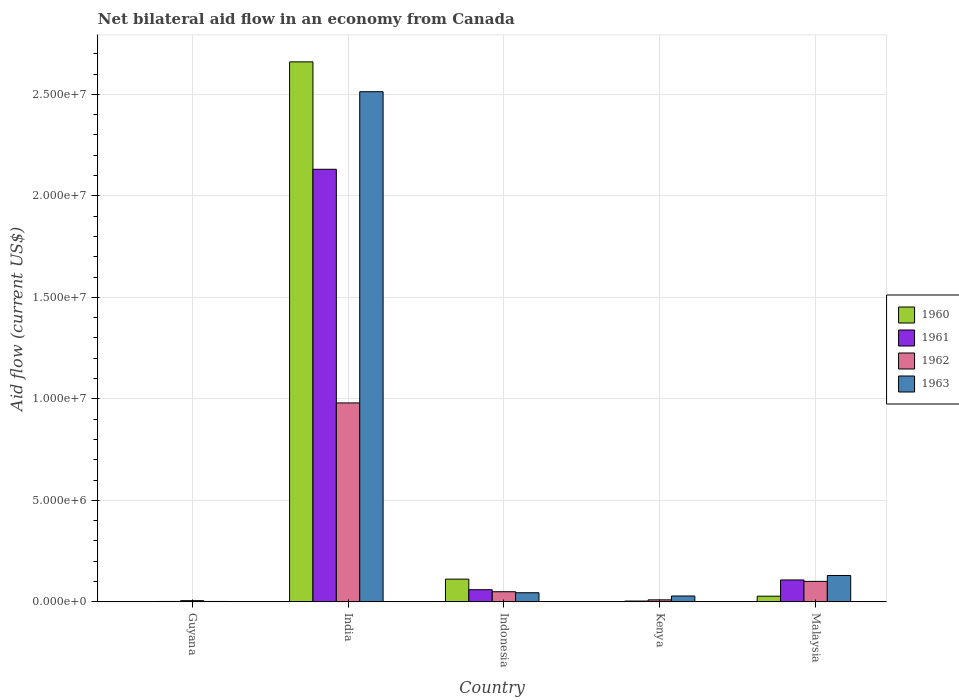How many different coloured bars are there?
Your answer should be very brief. 4. How many groups of bars are there?
Provide a short and direct response. 5. How many bars are there on the 1st tick from the left?
Make the answer very short. 4. What is the label of the 1st group of bars from the left?
Provide a short and direct response. Guyana. In how many cases, is the number of bars for a given country not equal to the number of legend labels?
Your answer should be compact. 0. What is the net bilateral aid flow in 1963 in Guyana?
Make the answer very short. 2.00e+04. Across all countries, what is the maximum net bilateral aid flow in 1963?
Keep it short and to the point. 2.51e+07. In which country was the net bilateral aid flow in 1960 minimum?
Provide a short and direct response. Guyana. What is the total net bilateral aid flow in 1961 in the graph?
Your answer should be compact. 2.30e+07. What is the difference between the net bilateral aid flow in 1961 in Guyana and that in Indonesia?
Keep it short and to the point. -5.80e+05. What is the difference between the net bilateral aid flow in 1963 in Kenya and the net bilateral aid flow in 1960 in India?
Keep it short and to the point. -2.63e+07. What is the average net bilateral aid flow in 1963 per country?
Your response must be concise. 5.44e+06. What is the difference between the net bilateral aid flow of/in 1963 and net bilateral aid flow of/in 1962 in India?
Your answer should be compact. 1.53e+07. In how many countries, is the net bilateral aid flow in 1961 greater than 24000000 US$?
Provide a short and direct response. 0. What is the ratio of the net bilateral aid flow in 1960 in Kenya to that in Malaysia?
Keep it short and to the point. 0.04. Is the difference between the net bilateral aid flow in 1963 in India and Malaysia greater than the difference between the net bilateral aid flow in 1962 in India and Malaysia?
Your answer should be compact. Yes. What is the difference between the highest and the second highest net bilateral aid flow in 1961?
Provide a succinct answer. 2.07e+07. What is the difference between the highest and the lowest net bilateral aid flow in 1961?
Provide a succinct answer. 2.13e+07. In how many countries, is the net bilateral aid flow in 1960 greater than the average net bilateral aid flow in 1960 taken over all countries?
Your answer should be compact. 1. Is it the case that in every country, the sum of the net bilateral aid flow in 1960 and net bilateral aid flow in 1961 is greater than the sum of net bilateral aid flow in 1963 and net bilateral aid flow in 1962?
Provide a succinct answer. No. What does the 3rd bar from the left in Indonesia represents?
Keep it short and to the point. 1962. What does the 1st bar from the right in Kenya represents?
Offer a terse response. 1963. Are all the bars in the graph horizontal?
Offer a very short reply. No. How many countries are there in the graph?
Make the answer very short. 5. What is the difference between two consecutive major ticks on the Y-axis?
Offer a terse response. 5.00e+06. Are the values on the major ticks of Y-axis written in scientific E-notation?
Your response must be concise. Yes. Where does the legend appear in the graph?
Give a very brief answer. Center right. How are the legend labels stacked?
Ensure brevity in your answer.  Vertical. What is the title of the graph?
Provide a short and direct response. Net bilateral aid flow in an economy from Canada. Does "1985" appear as one of the legend labels in the graph?
Provide a succinct answer. No. What is the label or title of the Y-axis?
Give a very brief answer. Aid flow (current US$). What is the Aid flow (current US$) of 1960 in Guyana?
Make the answer very short. 10000. What is the Aid flow (current US$) in 1961 in Guyana?
Provide a short and direct response. 2.00e+04. What is the Aid flow (current US$) in 1962 in Guyana?
Offer a terse response. 6.00e+04. What is the Aid flow (current US$) in 1960 in India?
Make the answer very short. 2.66e+07. What is the Aid flow (current US$) of 1961 in India?
Ensure brevity in your answer.  2.13e+07. What is the Aid flow (current US$) of 1962 in India?
Your answer should be very brief. 9.80e+06. What is the Aid flow (current US$) in 1963 in India?
Ensure brevity in your answer.  2.51e+07. What is the Aid flow (current US$) in 1960 in Indonesia?
Make the answer very short. 1.12e+06. What is the Aid flow (current US$) of 1961 in Indonesia?
Provide a short and direct response. 6.00e+05. What is the Aid flow (current US$) of 1962 in Indonesia?
Your answer should be very brief. 5.00e+05. What is the Aid flow (current US$) in 1961 in Kenya?
Give a very brief answer. 4.00e+04. What is the Aid flow (current US$) of 1961 in Malaysia?
Ensure brevity in your answer.  1.08e+06. What is the Aid flow (current US$) in 1962 in Malaysia?
Offer a very short reply. 1.01e+06. What is the Aid flow (current US$) in 1963 in Malaysia?
Provide a succinct answer. 1.30e+06. Across all countries, what is the maximum Aid flow (current US$) of 1960?
Ensure brevity in your answer.  2.66e+07. Across all countries, what is the maximum Aid flow (current US$) in 1961?
Your answer should be very brief. 2.13e+07. Across all countries, what is the maximum Aid flow (current US$) in 1962?
Your answer should be very brief. 9.80e+06. Across all countries, what is the maximum Aid flow (current US$) in 1963?
Provide a short and direct response. 2.51e+07. Across all countries, what is the minimum Aid flow (current US$) of 1960?
Offer a very short reply. 10000. Across all countries, what is the minimum Aid flow (current US$) of 1961?
Provide a short and direct response. 2.00e+04. What is the total Aid flow (current US$) of 1960 in the graph?
Make the answer very short. 2.80e+07. What is the total Aid flow (current US$) in 1961 in the graph?
Make the answer very short. 2.30e+07. What is the total Aid flow (current US$) in 1962 in the graph?
Offer a very short reply. 1.15e+07. What is the total Aid flow (current US$) in 1963 in the graph?
Your answer should be compact. 2.72e+07. What is the difference between the Aid flow (current US$) in 1960 in Guyana and that in India?
Offer a terse response. -2.66e+07. What is the difference between the Aid flow (current US$) in 1961 in Guyana and that in India?
Your response must be concise. -2.13e+07. What is the difference between the Aid flow (current US$) in 1962 in Guyana and that in India?
Make the answer very short. -9.74e+06. What is the difference between the Aid flow (current US$) in 1963 in Guyana and that in India?
Ensure brevity in your answer.  -2.51e+07. What is the difference between the Aid flow (current US$) of 1960 in Guyana and that in Indonesia?
Ensure brevity in your answer.  -1.11e+06. What is the difference between the Aid flow (current US$) of 1961 in Guyana and that in Indonesia?
Ensure brevity in your answer.  -5.80e+05. What is the difference between the Aid flow (current US$) in 1962 in Guyana and that in Indonesia?
Your response must be concise. -4.40e+05. What is the difference between the Aid flow (current US$) in 1963 in Guyana and that in Indonesia?
Provide a succinct answer. -4.30e+05. What is the difference between the Aid flow (current US$) in 1960 in Guyana and that in Kenya?
Offer a terse response. 0. What is the difference between the Aid flow (current US$) of 1961 in Guyana and that in Kenya?
Ensure brevity in your answer.  -2.00e+04. What is the difference between the Aid flow (current US$) of 1961 in Guyana and that in Malaysia?
Offer a terse response. -1.06e+06. What is the difference between the Aid flow (current US$) in 1962 in Guyana and that in Malaysia?
Make the answer very short. -9.50e+05. What is the difference between the Aid flow (current US$) in 1963 in Guyana and that in Malaysia?
Offer a very short reply. -1.28e+06. What is the difference between the Aid flow (current US$) in 1960 in India and that in Indonesia?
Give a very brief answer. 2.55e+07. What is the difference between the Aid flow (current US$) in 1961 in India and that in Indonesia?
Give a very brief answer. 2.07e+07. What is the difference between the Aid flow (current US$) of 1962 in India and that in Indonesia?
Offer a terse response. 9.30e+06. What is the difference between the Aid flow (current US$) of 1963 in India and that in Indonesia?
Keep it short and to the point. 2.47e+07. What is the difference between the Aid flow (current US$) in 1960 in India and that in Kenya?
Provide a short and direct response. 2.66e+07. What is the difference between the Aid flow (current US$) in 1961 in India and that in Kenya?
Offer a very short reply. 2.13e+07. What is the difference between the Aid flow (current US$) in 1962 in India and that in Kenya?
Provide a succinct answer. 9.70e+06. What is the difference between the Aid flow (current US$) in 1963 in India and that in Kenya?
Your response must be concise. 2.48e+07. What is the difference between the Aid flow (current US$) of 1960 in India and that in Malaysia?
Make the answer very short. 2.63e+07. What is the difference between the Aid flow (current US$) in 1961 in India and that in Malaysia?
Your answer should be compact. 2.02e+07. What is the difference between the Aid flow (current US$) of 1962 in India and that in Malaysia?
Your answer should be very brief. 8.79e+06. What is the difference between the Aid flow (current US$) in 1963 in India and that in Malaysia?
Ensure brevity in your answer.  2.38e+07. What is the difference between the Aid flow (current US$) in 1960 in Indonesia and that in Kenya?
Your answer should be compact. 1.11e+06. What is the difference between the Aid flow (current US$) of 1961 in Indonesia and that in Kenya?
Keep it short and to the point. 5.60e+05. What is the difference between the Aid flow (current US$) of 1962 in Indonesia and that in Kenya?
Your answer should be very brief. 4.00e+05. What is the difference between the Aid flow (current US$) of 1960 in Indonesia and that in Malaysia?
Your response must be concise. 8.40e+05. What is the difference between the Aid flow (current US$) of 1961 in Indonesia and that in Malaysia?
Offer a terse response. -4.80e+05. What is the difference between the Aid flow (current US$) of 1962 in Indonesia and that in Malaysia?
Make the answer very short. -5.10e+05. What is the difference between the Aid flow (current US$) of 1963 in Indonesia and that in Malaysia?
Provide a short and direct response. -8.50e+05. What is the difference between the Aid flow (current US$) in 1961 in Kenya and that in Malaysia?
Provide a succinct answer. -1.04e+06. What is the difference between the Aid flow (current US$) in 1962 in Kenya and that in Malaysia?
Offer a very short reply. -9.10e+05. What is the difference between the Aid flow (current US$) of 1963 in Kenya and that in Malaysia?
Your answer should be compact. -1.01e+06. What is the difference between the Aid flow (current US$) of 1960 in Guyana and the Aid flow (current US$) of 1961 in India?
Give a very brief answer. -2.13e+07. What is the difference between the Aid flow (current US$) in 1960 in Guyana and the Aid flow (current US$) in 1962 in India?
Your response must be concise. -9.79e+06. What is the difference between the Aid flow (current US$) in 1960 in Guyana and the Aid flow (current US$) in 1963 in India?
Make the answer very short. -2.51e+07. What is the difference between the Aid flow (current US$) of 1961 in Guyana and the Aid flow (current US$) of 1962 in India?
Ensure brevity in your answer.  -9.78e+06. What is the difference between the Aid flow (current US$) in 1961 in Guyana and the Aid flow (current US$) in 1963 in India?
Keep it short and to the point. -2.51e+07. What is the difference between the Aid flow (current US$) of 1962 in Guyana and the Aid flow (current US$) of 1963 in India?
Keep it short and to the point. -2.51e+07. What is the difference between the Aid flow (current US$) of 1960 in Guyana and the Aid flow (current US$) of 1961 in Indonesia?
Offer a terse response. -5.90e+05. What is the difference between the Aid flow (current US$) of 1960 in Guyana and the Aid flow (current US$) of 1962 in Indonesia?
Provide a short and direct response. -4.90e+05. What is the difference between the Aid flow (current US$) in 1960 in Guyana and the Aid flow (current US$) in 1963 in Indonesia?
Your response must be concise. -4.40e+05. What is the difference between the Aid flow (current US$) of 1961 in Guyana and the Aid flow (current US$) of 1962 in Indonesia?
Offer a terse response. -4.80e+05. What is the difference between the Aid flow (current US$) of 1961 in Guyana and the Aid flow (current US$) of 1963 in Indonesia?
Offer a very short reply. -4.30e+05. What is the difference between the Aid flow (current US$) in 1962 in Guyana and the Aid flow (current US$) in 1963 in Indonesia?
Provide a succinct answer. -3.90e+05. What is the difference between the Aid flow (current US$) of 1960 in Guyana and the Aid flow (current US$) of 1963 in Kenya?
Your answer should be very brief. -2.80e+05. What is the difference between the Aid flow (current US$) in 1961 in Guyana and the Aid flow (current US$) in 1962 in Kenya?
Make the answer very short. -8.00e+04. What is the difference between the Aid flow (current US$) in 1962 in Guyana and the Aid flow (current US$) in 1963 in Kenya?
Your response must be concise. -2.30e+05. What is the difference between the Aid flow (current US$) in 1960 in Guyana and the Aid flow (current US$) in 1961 in Malaysia?
Ensure brevity in your answer.  -1.07e+06. What is the difference between the Aid flow (current US$) in 1960 in Guyana and the Aid flow (current US$) in 1962 in Malaysia?
Make the answer very short. -1.00e+06. What is the difference between the Aid flow (current US$) in 1960 in Guyana and the Aid flow (current US$) in 1963 in Malaysia?
Ensure brevity in your answer.  -1.29e+06. What is the difference between the Aid flow (current US$) of 1961 in Guyana and the Aid flow (current US$) of 1962 in Malaysia?
Your response must be concise. -9.90e+05. What is the difference between the Aid flow (current US$) in 1961 in Guyana and the Aid flow (current US$) in 1963 in Malaysia?
Keep it short and to the point. -1.28e+06. What is the difference between the Aid flow (current US$) of 1962 in Guyana and the Aid flow (current US$) of 1963 in Malaysia?
Give a very brief answer. -1.24e+06. What is the difference between the Aid flow (current US$) of 1960 in India and the Aid flow (current US$) of 1961 in Indonesia?
Keep it short and to the point. 2.60e+07. What is the difference between the Aid flow (current US$) in 1960 in India and the Aid flow (current US$) in 1962 in Indonesia?
Provide a succinct answer. 2.61e+07. What is the difference between the Aid flow (current US$) of 1960 in India and the Aid flow (current US$) of 1963 in Indonesia?
Keep it short and to the point. 2.62e+07. What is the difference between the Aid flow (current US$) of 1961 in India and the Aid flow (current US$) of 1962 in Indonesia?
Provide a short and direct response. 2.08e+07. What is the difference between the Aid flow (current US$) in 1961 in India and the Aid flow (current US$) in 1963 in Indonesia?
Your answer should be very brief. 2.09e+07. What is the difference between the Aid flow (current US$) in 1962 in India and the Aid flow (current US$) in 1963 in Indonesia?
Provide a short and direct response. 9.35e+06. What is the difference between the Aid flow (current US$) of 1960 in India and the Aid flow (current US$) of 1961 in Kenya?
Your answer should be very brief. 2.66e+07. What is the difference between the Aid flow (current US$) of 1960 in India and the Aid flow (current US$) of 1962 in Kenya?
Make the answer very short. 2.65e+07. What is the difference between the Aid flow (current US$) of 1960 in India and the Aid flow (current US$) of 1963 in Kenya?
Your answer should be compact. 2.63e+07. What is the difference between the Aid flow (current US$) of 1961 in India and the Aid flow (current US$) of 1962 in Kenya?
Offer a terse response. 2.12e+07. What is the difference between the Aid flow (current US$) of 1961 in India and the Aid flow (current US$) of 1963 in Kenya?
Give a very brief answer. 2.10e+07. What is the difference between the Aid flow (current US$) in 1962 in India and the Aid flow (current US$) in 1963 in Kenya?
Make the answer very short. 9.51e+06. What is the difference between the Aid flow (current US$) of 1960 in India and the Aid flow (current US$) of 1961 in Malaysia?
Keep it short and to the point. 2.55e+07. What is the difference between the Aid flow (current US$) of 1960 in India and the Aid flow (current US$) of 1962 in Malaysia?
Offer a terse response. 2.56e+07. What is the difference between the Aid flow (current US$) of 1960 in India and the Aid flow (current US$) of 1963 in Malaysia?
Give a very brief answer. 2.53e+07. What is the difference between the Aid flow (current US$) of 1961 in India and the Aid flow (current US$) of 1962 in Malaysia?
Make the answer very short. 2.03e+07. What is the difference between the Aid flow (current US$) of 1961 in India and the Aid flow (current US$) of 1963 in Malaysia?
Provide a succinct answer. 2.00e+07. What is the difference between the Aid flow (current US$) in 1962 in India and the Aid flow (current US$) in 1963 in Malaysia?
Give a very brief answer. 8.50e+06. What is the difference between the Aid flow (current US$) in 1960 in Indonesia and the Aid flow (current US$) in 1961 in Kenya?
Your response must be concise. 1.08e+06. What is the difference between the Aid flow (current US$) in 1960 in Indonesia and the Aid flow (current US$) in 1962 in Kenya?
Provide a succinct answer. 1.02e+06. What is the difference between the Aid flow (current US$) in 1960 in Indonesia and the Aid flow (current US$) in 1963 in Kenya?
Your answer should be compact. 8.30e+05. What is the difference between the Aid flow (current US$) of 1961 in Indonesia and the Aid flow (current US$) of 1962 in Kenya?
Give a very brief answer. 5.00e+05. What is the difference between the Aid flow (current US$) of 1961 in Indonesia and the Aid flow (current US$) of 1963 in Kenya?
Give a very brief answer. 3.10e+05. What is the difference between the Aid flow (current US$) of 1962 in Indonesia and the Aid flow (current US$) of 1963 in Kenya?
Give a very brief answer. 2.10e+05. What is the difference between the Aid flow (current US$) of 1960 in Indonesia and the Aid flow (current US$) of 1962 in Malaysia?
Your answer should be compact. 1.10e+05. What is the difference between the Aid flow (current US$) in 1960 in Indonesia and the Aid flow (current US$) in 1963 in Malaysia?
Your answer should be compact. -1.80e+05. What is the difference between the Aid flow (current US$) of 1961 in Indonesia and the Aid flow (current US$) of 1962 in Malaysia?
Make the answer very short. -4.10e+05. What is the difference between the Aid flow (current US$) of 1961 in Indonesia and the Aid flow (current US$) of 1963 in Malaysia?
Provide a succinct answer. -7.00e+05. What is the difference between the Aid flow (current US$) in 1962 in Indonesia and the Aid flow (current US$) in 1963 in Malaysia?
Your answer should be very brief. -8.00e+05. What is the difference between the Aid flow (current US$) of 1960 in Kenya and the Aid flow (current US$) of 1961 in Malaysia?
Offer a terse response. -1.07e+06. What is the difference between the Aid flow (current US$) of 1960 in Kenya and the Aid flow (current US$) of 1963 in Malaysia?
Keep it short and to the point. -1.29e+06. What is the difference between the Aid flow (current US$) of 1961 in Kenya and the Aid flow (current US$) of 1962 in Malaysia?
Your answer should be very brief. -9.70e+05. What is the difference between the Aid flow (current US$) in 1961 in Kenya and the Aid flow (current US$) in 1963 in Malaysia?
Provide a short and direct response. -1.26e+06. What is the difference between the Aid flow (current US$) of 1962 in Kenya and the Aid flow (current US$) of 1963 in Malaysia?
Offer a very short reply. -1.20e+06. What is the average Aid flow (current US$) of 1960 per country?
Your response must be concise. 5.60e+06. What is the average Aid flow (current US$) of 1961 per country?
Your response must be concise. 4.61e+06. What is the average Aid flow (current US$) in 1962 per country?
Your answer should be compact. 2.29e+06. What is the average Aid flow (current US$) of 1963 per country?
Your answer should be compact. 5.44e+06. What is the difference between the Aid flow (current US$) of 1960 and Aid flow (current US$) of 1961 in Guyana?
Ensure brevity in your answer.  -10000. What is the difference between the Aid flow (current US$) of 1961 and Aid flow (current US$) of 1962 in Guyana?
Offer a terse response. -4.00e+04. What is the difference between the Aid flow (current US$) in 1960 and Aid flow (current US$) in 1961 in India?
Keep it short and to the point. 5.29e+06. What is the difference between the Aid flow (current US$) of 1960 and Aid flow (current US$) of 1962 in India?
Your answer should be compact. 1.68e+07. What is the difference between the Aid flow (current US$) of 1960 and Aid flow (current US$) of 1963 in India?
Keep it short and to the point. 1.47e+06. What is the difference between the Aid flow (current US$) in 1961 and Aid flow (current US$) in 1962 in India?
Offer a terse response. 1.15e+07. What is the difference between the Aid flow (current US$) in 1961 and Aid flow (current US$) in 1963 in India?
Offer a terse response. -3.82e+06. What is the difference between the Aid flow (current US$) in 1962 and Aid flow (current US$) in 1963 in India?
Provide a short and direct response. -1.53e+07. What is the difference between the Aid flow (current US$) in 1960 and Aid flow (current US$) in 1961 in Indonesia?
Offer a terse response. 5.20e+05. What is the difference between the Aid flow (current US$) in 1960 and Aid flow (current US$) in 1962 in Indonesia?
Keep it short and to the point. 6.20e+05. What is the difference between the Aid flow (current US$) of 1960 and Aid flow (current US$) of 1963 in Indonesia?
Your answer should be very brief. 6.70e+05. What is the difference between the Aid flow (current US$) of 1962 and Aid flow (current US$) of 1963 in Indonesia?
Your response must be concise. 5.00e+04. What is the difference between the Aid flow (current US$) in 1960 and Aid flow (current US$) in 1963 in Kenya?
Make the answer very short. -2.80e+05. What is the difference between the Aid flow (current US$) in 1962 and Aid flow (current US$) in 1963 in Kenya?
Give a very brief answer. -1.90e+05. What is the difference between the Aid flow (current US$) of 1960 and Aid flow (current US$) of 1961 in Malaysia?
Provide a short and direct response. -8.00e+05. What is the difference between the Aid flow (current US$) of 1960 and Aid flow (current US$) of 1962 in Malaysia?
Offer a very short reply. -7.30e+05. What is the difference between the Aid flow (current US$) in 1960 and Aid flow (current US$) in 1963 in Malaysia?
Offer a very short reply. -1.02e+06. What is the difference between the Aid flow (current US$) of 1962 and Aid flow (current US$) of 1963 in Malaysia?
Offer a terse response. -2.90e+05. What is the ratio of the Aid flow (current US$) in 1960 in Guyana to that in India?
Offer a very short reply. 0. What is the ratio of the Aid flow (current US$) in 1961 in Guyana to that in India?
Your answer should be compact. 0. What is the ratio of the Aid flow (current US$) of 1962 in Guyana to that in India?
Offer a very short reply. 0.01. What is the ratio of the Aid flow (current US$) in 1963 in Guyana to that in India?
Your answer should be compact. 0. What is the ratio of the Aid flow (current US$) in 1960 in Guyana to that in Indonesia?
Keep it short and to the point. 0.01. What is the ratio of the Aid flow (current US$) of 1961 in Guyana to that in Indonesia?
Your answer should be very brief. 0.03. What is the ratio of the Aid flow (current US$) of 1962 in Guyana to that in Indonesia?
Your answer should be very brief. 0.12. What is the ratio of the Aid flow (current US$) of 1963 in Guyana to that in Indonesia?
Provide a short and direct response. 0.04. What is the ratio of the Aid flow (current US$) of 1962 in Guyana to that in Kenya?
Provide a succinct answer. 0.6. What is the ratio of the Aid flow (current US$) in 1963 in Guyana to that in Kenya?
Provide a short and direct response. 0.07. What is the ratio of the Aid flow (current US$) in 1960 in Guyana to that in Malaysia?
Offer a terse response. 0.04. What is the ratio of the Aid flow (current US$) in 1961 in Guyana to that in Malaysia?
Offer a terse response. 0.02. What is the ratio of the Aid flow (current US$) of 1962 in Guyana to that in Malaysia?
Offer a terse response. 0.06. What is the ratio of the Aid flow (current US$) of 1963 in Guyana to that in Malaysia?
Your response must be concise. 0.02. What is the ratio of the Aid flow (current US$) of 1960 in India to that in Indonesia?
Your answer should be compact. 23.75. What is the ratio of the Aid flow (current US$) in 1961 in India to that in Indonesia?
Your response must be concise. 35.52. What is the ratio of the Aid flow (current US$) of 1962 in India to that in Indonesia?
Your answer should be very brief. 19.6. What is the ratio of the Aid flow (current US$) in 1963 in India to that in Indonesia?
Offer a terse response. 55.84. What is the ratio of the Aid flow (current US$) in 1960 in India to that in Kenya?
Offer a terse response. 2660. What is the ratio of the Aid flow (current US$) in 1961 in India to that in Kenya?
Make the answer very short. 532.75. What is the ratio of the Aid flow (current US$) in 1963 in India to that in Kenya?
Ensure brevity in your answer.  86.66. What is the ratio of the Aid flow (current US$) of 1960 in India to that in Malaysia?
Make the answer very short. 95. What is the ratio of the Aid flow (current US$) of 1961 in India to that in Malaysia?
Offer a terse response. 19.73. What is the ratio of the Aid flow (current US$) in 1962 in India to that in Malaysia?
Your answer should be very brief. 9.7. What is the ratio of the Aid flow (current US$) in 1963 in India to that in Malaysia?
Your answer should be very brief. 19.33. What is the ratio of the Aid flow (current US$) of 1960 in Indonesia to that in Kenya?
Ensure brevity in your answer.  112. What is the ratio of the Aid flow (current US$) in 1961 in Indonesia to that in Kenya?
Make the answer very short. 15. What is the ratio of the Aid flow (current US$) in 1962 in Indonesia to that in Kenya?
Your answer should be compact. 5. What is the ratio of the Aid flow (current US$) in 1963 in Indonesia to that in Kenya?
Provide a short and direct response. 1.55. What is the ratio of the Aid flow (current US$) in 1961 in Indonesia to that in Malaysia?
Make the answer very short. 0.56. What is the ratio of the Aid flow (current US$) in 1962 in Indonesia to that in Malaysia?
Provide a succinct answer. 0.49. What is the ratio of the Aid flow (current US$) of 1963 in Indonesia to that in Malaysia?
Provide a short and direct response. 0.35. What is the ratio of the Aid flow (current US$) in 1960 in Kenya to that in Malaysia?
Offer a terse response. 0.04. What is the ratio of the Aid flow (current US$) of 1961 in Kenya to that in Malaysia?
Your answer should be compact. 0.04. What is the ratio of the Aid flow (current US$) of 1962 in Kenya to that in Malaysia?
Provide a succinct answer. 0.1. What is the ratio of the Aid flow (current US$) of 1963 in Kenya to that in Malaysia?
Your answer should be very brief. 0.22. What is the difference between the highest and the second highest Aid flow (current US$) in 1960?
Offer a very short reply. 2.55e+07. What is the difference between the highest and the second highest Aid flow (current US$) in 1961?
Make the answer very short. 2.02e+07. What is the difference between the highest and the second highest Aid flow (current US$) of 1962?
Give a very brief answer. 8.79e+06. What is the difference between the highest and the second highest Aid flow (current US$) in 1963?
Make the answer very short. 2.38e+07. What is the difference between the highest and the lowest Aid flow (current US$) in 1960?
Your answer should be compact. 2.66e+07. What is the difference between the highest and the lowest Aid flow (current US$) of 1961?
Your answer should be very brief. 2.13e+07. What is the difference between the highest and the lowest Aid flow (current US$) of 1962?
Provide a succinct answer. 9.74e+06. What is the difference between the highest and the lowest Aid flow (current US$) of 1963?
Offer a very short reply. 2.51e+07. 